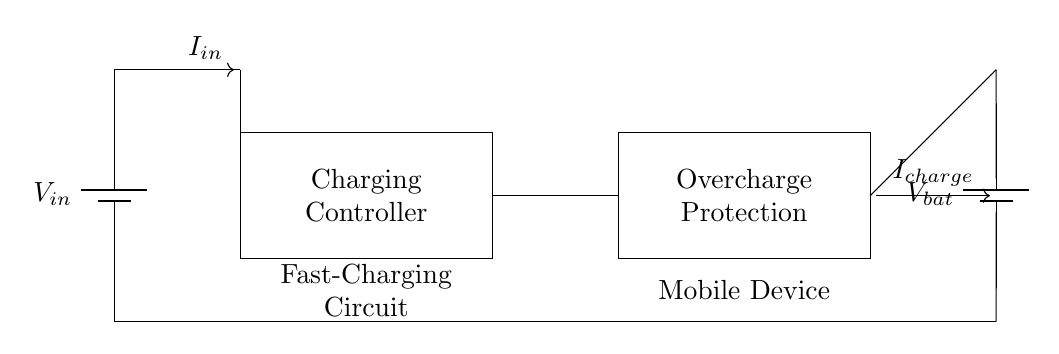What component is responsible for controlling the charging process? The charging controller is marked in the rectangle labeled with that name. It oversees the proper charging conditions for the battery.
Answer: Charging Controller What is the purpose of the overcharge protection? The overcharge protection component is specifically labeled and designed to prevent the battery from being charged beyond its maximum voltage. This helps in enhancing the battery's lifespan and safety.
Answer: Prevent overcharging What are the input and output voltages indicated in the circuit? The input voltage is labeled as V_in and the output voltage from the battery is labeled as V_bat. These labels represent the voltage sources used and generated, respectively.
Answer: V_in and V_bat Which direction does the current flow in the circuit? The current flows from the power source labeled V_in towards the charging controller, indicated by the arrow labeled I_in. It then moves towards the battery, marked as I_charge.
Answer: Left to right What kind of circuit is represented? The circuit is a fast-charging circuit specifically tailored for mobile devices and includes features for overcharge protection. This classification highlights its purpose for rapid, safe charging.
Answer: Fast-Charging Circuit How many battery components are present in this circuit? The circuit diagram contains two batteries, one serving as the input power source (V_in) and the other representing the output battery (V_bat) to be charged.
Answer: Two batteries What safety feature in this circuit is explicitly aimed at increasing battery safety? The overcharge protection feature is intended to enhance battery safety by ensuring it is not charged beyond its designated threshold, thereby preventing damage or failures.
Answer: Overcharge Protection 